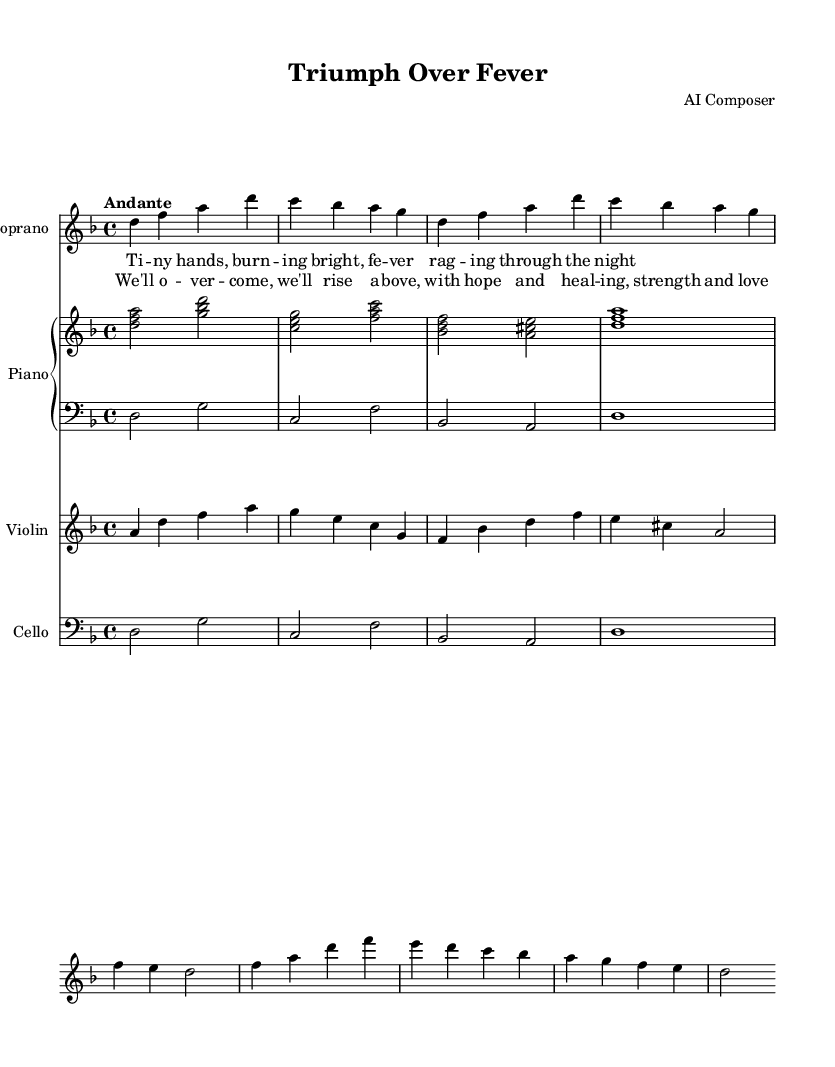What is the key signature of this music? The key signature is D minor, which has one flat (B flat). This can be identified at the beginning of the score where the key signature is indicated.
Answer: D minor What is the time signature of this music? The time signature is 4/4, as shown at the beginning of the score where the time signature is marked. This indicates that there are four beats in each measure, and a quarter note receives one beat.
Answer: 4/4 What is the tempo indication of this piece? The tempo indication is "Andante," which suggests a moderately slow tempo, typically around 76-108 beats per minute. This is noted at the start of the score.
Answer: Andante Which instrument plays the upper piano part? The upper piano part is labeled under "Piano," indicating that it is to be played by the pianist’s right hand. This can be inferred by its placement in the score under the 'PianoStaff' section.
Answer: Piano What is the main theme of the chorus lyrics? The main theme of the chorus lyrics emphasizes resilience and hope in overcoming challenges, specifically referencing healing and strength. Analyzing the lyrics, the repetition of phrases like "We'll overcome" highlights this central theme.
Answer: Resilience and hope How many measures are in the introduction? There are four measures in the introduction, as indicated by the notation before the first verse begins. Each group of notes and rests makes up a separate measure, and they can be counted visually.
Answer: Four What type of musical piece is this? This piece is classified as an opera, as indicated by the overall theme and structure, which includes dramatic lyrics and vocal lines aimed at conveying emotional narratives, commonly found in operatic works.
Answer: Opera 